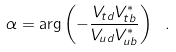Convert formula to latex. <formula><loc_0><loc_0><loc_500><loc_500>\alpha = \arg \left ( - \frac { V _ { t d } V _ { t b } ^ { * } } { V _ { u d } V _ { u b } ^ { * } } \right ) \ .</formula> 